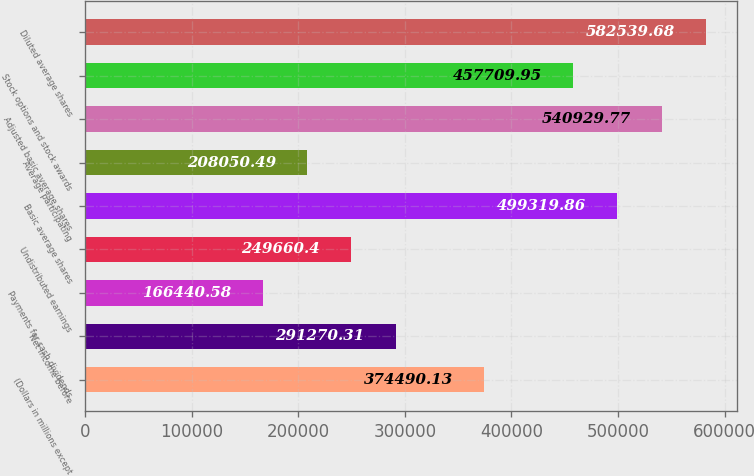Convert chart to OTSL. <chart><loc_0><loc_0><loc_500><loc_500><bar_chart><fcel>(Dollars in millions except<fcel>Net income before<fcel>Payments for cash dividends<fcel>Undistributed earnings<fcel>Basic average shares<fcel>Average participating<fcel>Adjusted basic average shares<fcel>Stock options and stock awards<fcel>Diluted average shares<nl><fcel>374490<fcel>291270<fcel>166441<fcel>249660<fcel>499320<fcel>208050<fcel>540930<fcel>457710<fcel>582540<nl></chart> 